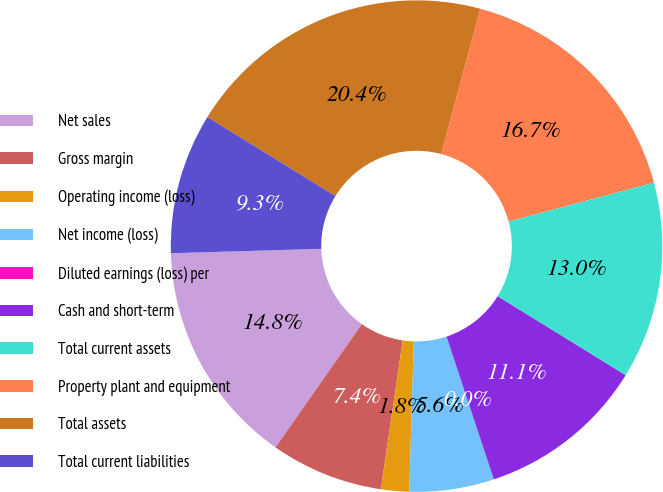Convert chart. <chart><loc_0><loc_0><loc_500><loc_500><pie_chart><fcel>Net sales<fcel>Gross margin<fcel>Operating income (loss)<fcel>Net income (loss)<fcel>Diluted earnings (loss) per<fcel>Cash and short-term<fcel>Total current assets<fcel>Property plant and equipment<fcel>Total assets<fcel>Total current liabilities<nl><fcel>14.81%<fcel>7.41%<fcel>1.85%<fcel>5.56%<fcel>0.0%<fcel>11.11%<fcel>12.96%<fcel>16.67%<fcel>20.37%<fcel>9.26%<nl></chart> 